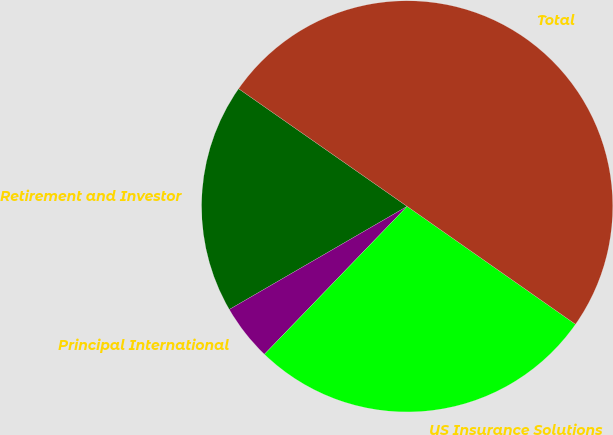Convert chart. <chart><loc_0><loc_0><loc_500><loc_500><pie_chart><fcel>Retirement and Investor<fcel>Principal International<fcel>US Insurance Solutions<fcel>Total<nl><fcel>18.06%<fcel>4.42%<fcel>27.49%<fcel>50.02%<nl></chart> 